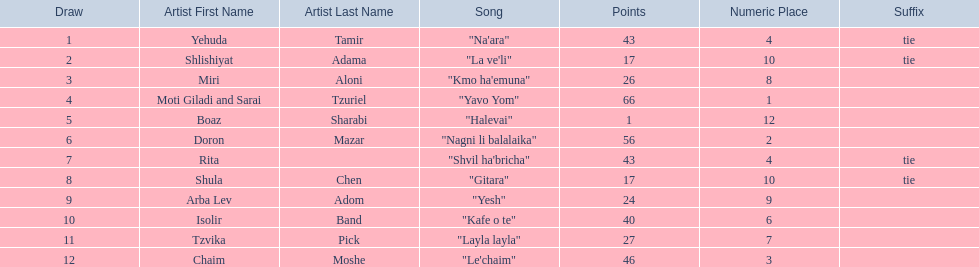What are the points in the competition? 43, 17, 26, 66, 1, 56, 43, 17, 24, 40, 27, 46. What is the lowest points? 1. What artist received these points? Boaz Sharabi. 